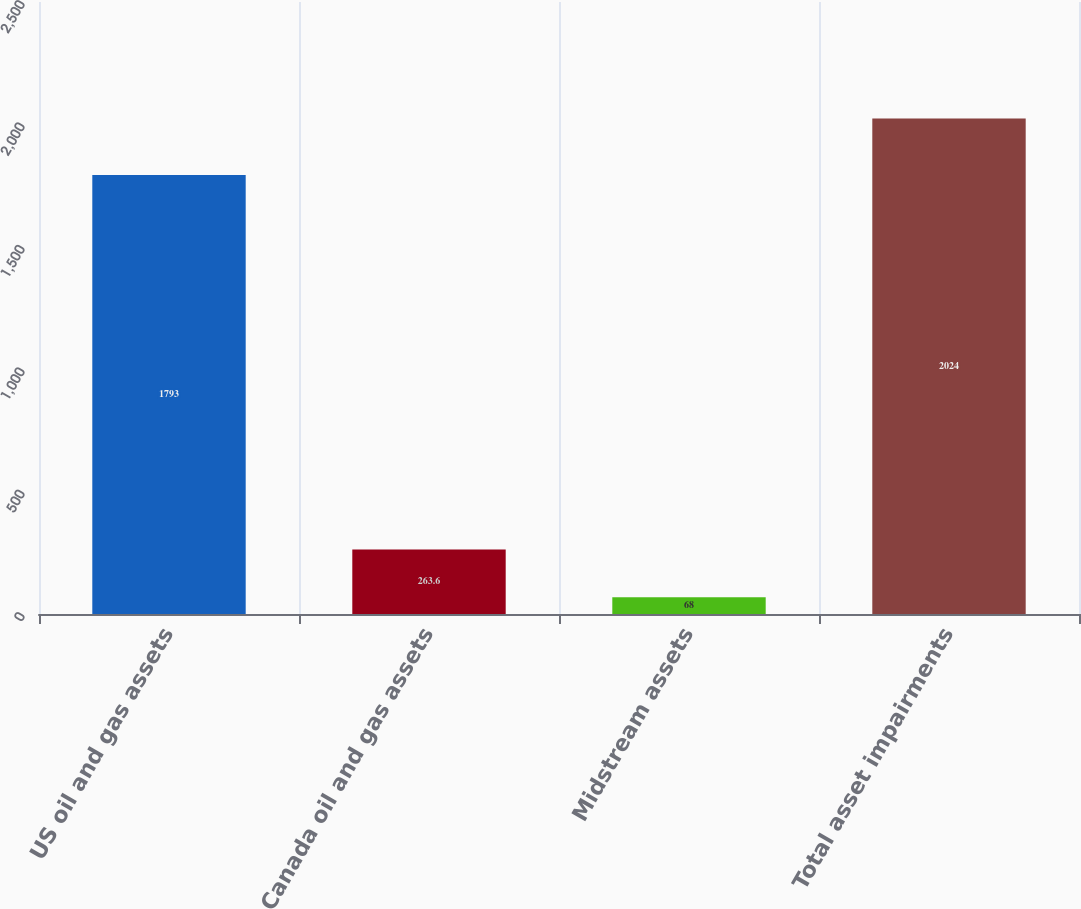<chart> <loc_0><loc_0><loc_500><loc_500><bar_chart><fcel>US oil and gas assets<fcel>Canada oil and gas assets<fcel>Midstream assets<fcel>Total asset impairments<nl><fcel>1793<fcel>263.6<fcel>68<fcel>2024<nl></chart> 